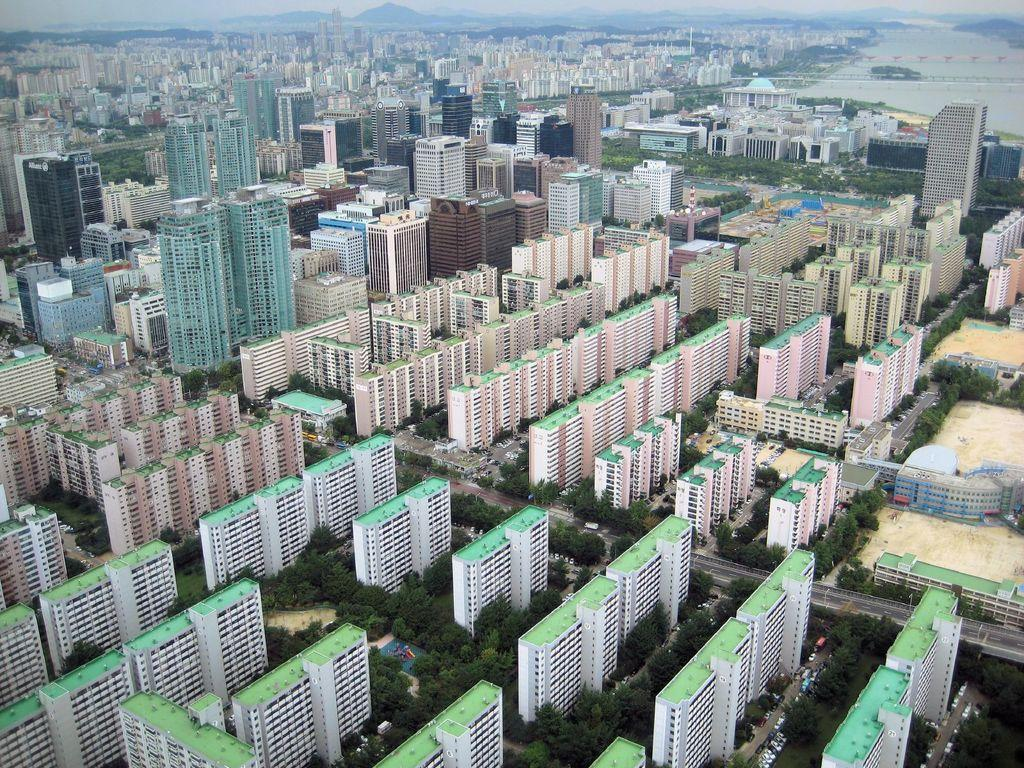What type of structures can be seen in the image? There are buildings in the image. What other natural elements are present in the image? There are trees and water visible in the image. What type of pathway is visible in the image? There is a road visible in the image. What geographical features can be seen in the image? There are hills in the image. What part of the natural environment is visible in the image? The sky is visible in the image. What news is being reported at the party in the image? There is no party or news present in the image; it features buildings, trees, a road, hills, water, and the sky. What type of cover is being used to protect the water in the image? There is no cover present in the image; the water is visible and not protected by any cover. 